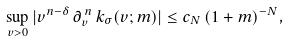<formula> <loc_0><loc_0><loc_500><loc_500>\sup _ { v > 0 } | v ^ { n - \delta } \, \partial _ { v } ^ { \, n } \, k _ { \sigma } ( v ; m ) | \leq c _ { N } \, ( 1 + m ) ^ { - N } ,</formula> 